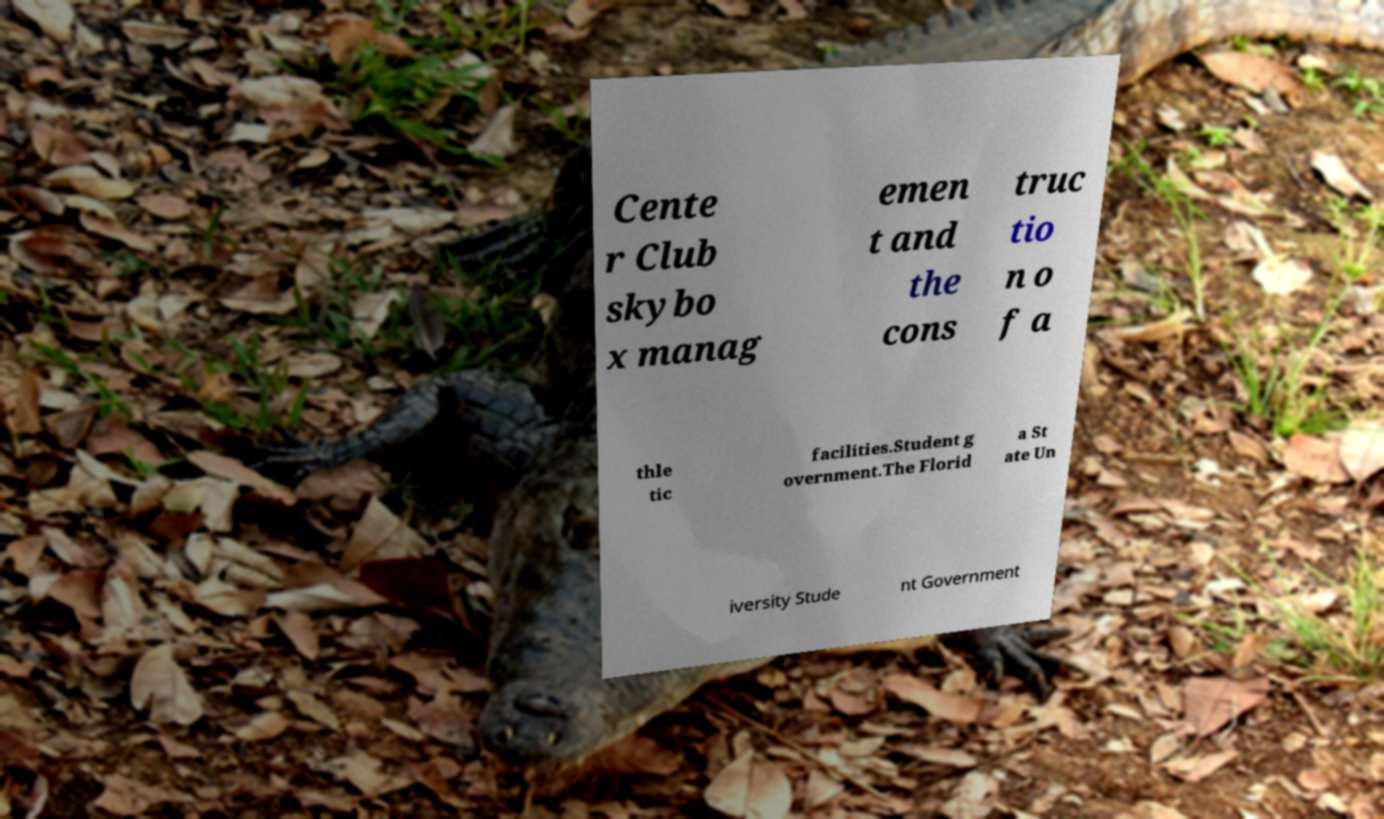What messages or text are displayed in this image? I need them in a readable, typed format. Cente r Club skybo x manag emen t and the cons truc tio n o f a thle tic facilities.Student g overnment.The Florid a St ate Un iversity Stude nt Government 